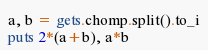Convert code to text. <code><loc_0><loc_0><loc_500><loc_500><_Ruby_>a, b = gets.chomp.split().to_i
puts 2*(a+b), a*b</code> 